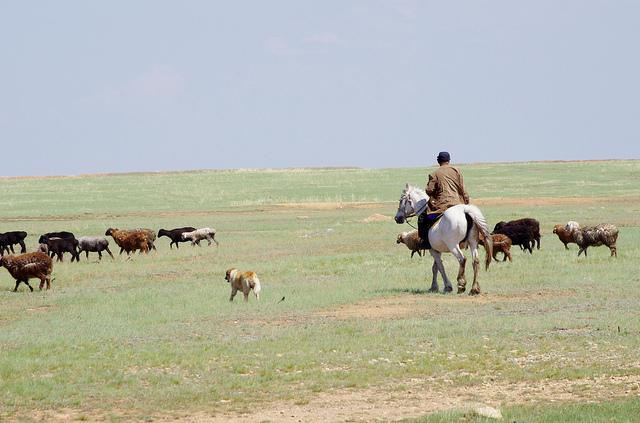How many horses are there?
Be succinct. 1. Why is there a dog in the photo?
Short answer required. Herding. Which direction is the back horse facing?
Short answer required. Left. How many cows are in the photo?
Write a very short answer. 13. What color are the horses?
Be succinct. White. What is the man herding that is riding the horse?
Answer briefly. Cows. Are all the animals the same color?
Short answer required. No. Is there trees in this picture?
Quick response, please. No. How many horses?
Keep it brief. 1. How many men are there?
Be succinct. 1. 